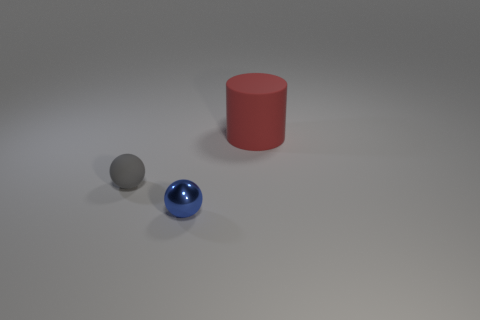Add 1 gray things. How many objects exist? 4 Subtract all blue spheres. How many spheres are left? 1 Subtract 0 gray cylinders. How many objects are left? 3 Subtract all cylinders. How many objects are left? 2 Subtract 2 balls. How many balls are left? 0 Subtract all yellow spheres. Subtract all brown cubes. How many spheres are left? 2 Subtract all red spheres. How many green cylinders are left? 0 Subtract all large green metal cylinders. Subtract all red objects. How many objects are left? 2 Add 2 red things. How many red things are left? 3 Add 3 blue things. How many blue things exist? 4 